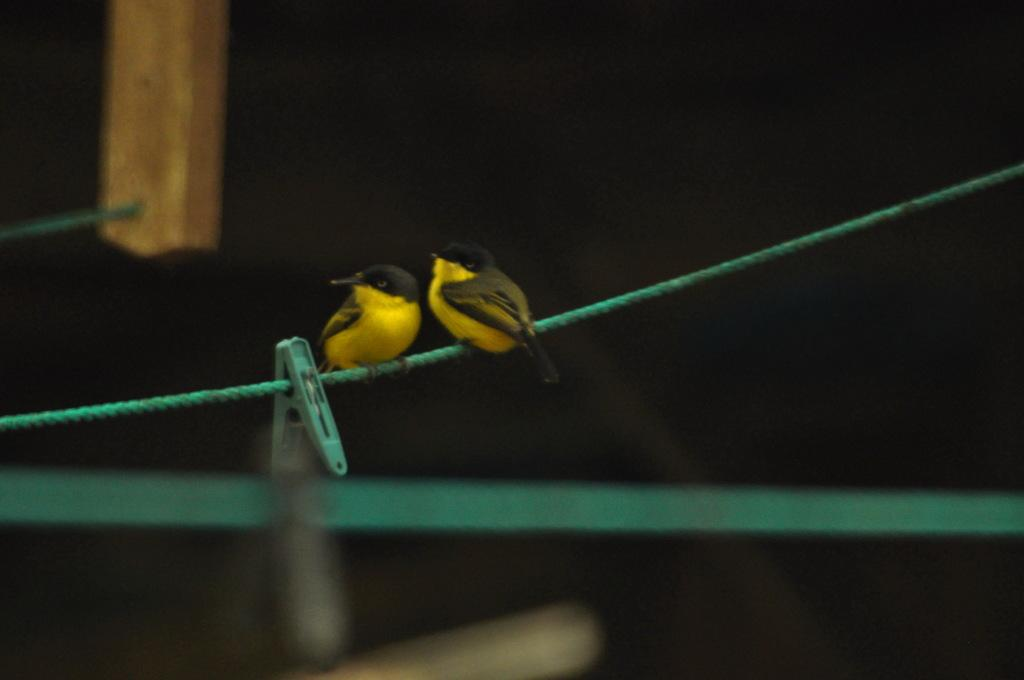How many birds are in the image? There are two birds in the image. What colors are the birds? The birds are in black and yellow color. What are the birds sitting on? The birds are sitting on a thread. What other object can be seen in the image? There is a clip in the image. What color is the clip? The clip is in green color. What is the health status of the birds in the image? There is no information about the health status of the birds in the image. Can you tell me what the birds are arguing about in the image? There is no indication of an argument between the birds in the image. 